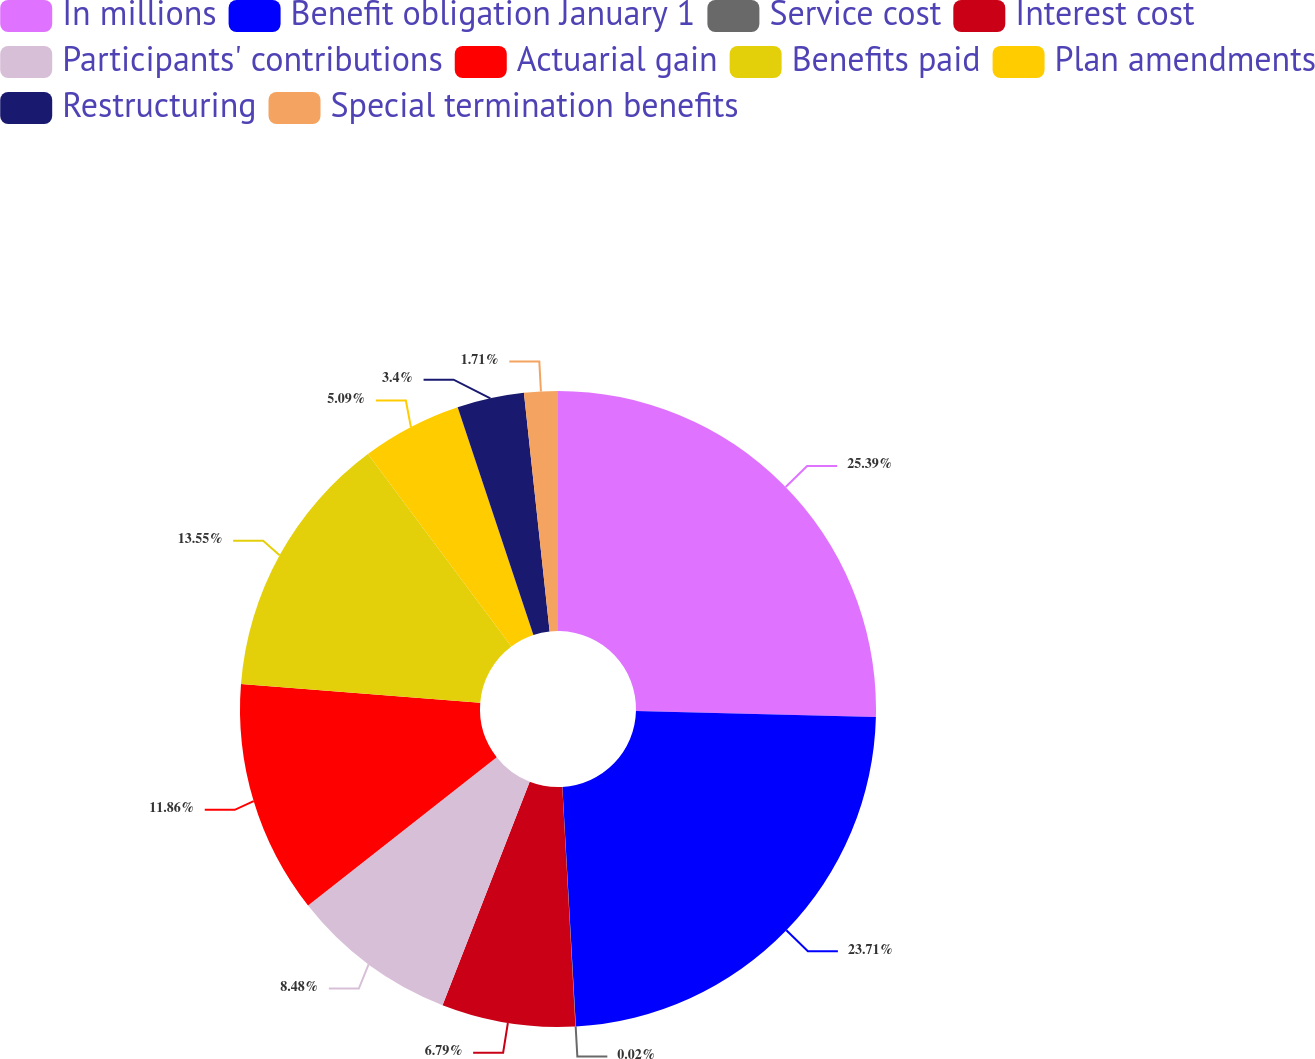<chart> <loc_0><loc_0><loc_500><loc_500><pie_chart><fcel>In millions<fcel>Benefit obligation January 1<fcel>Service cost<fcel>Interest cost<fcel>Participants' contributions<fcel>Actuarial gain<fcel>Benefits paid<fcel>Plan amendments<fcel>Restructuring<fcel>Special termination benefits<nl><fcel>25.4%<fcel>23.71%<fcel>0.02%<fcel>6.79%<fcel>8.48%<fcel>11.86%<fcel>13.55%<fcel>5.09%<fcel>3.4%<fcel>1.71%<nl></chart> 